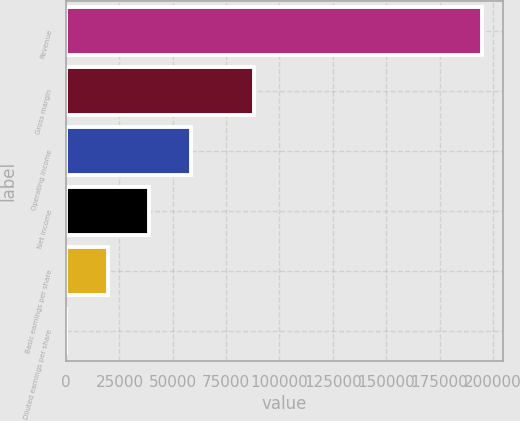Convert chart. <chart><loc_0><loc_0><loc_500><loc_500><bar_chart><fcel>Revenue<fcel>Gross margin<fcel>Operating income<fcel>Net income<fcel>Basic earnings per share<fcel>Diluted earnings per share<nl><fcel>195037<fcel>88116<fcel>58511.2<fcel>39007.5<fcel>19503.8<fcel>0.1<nl></chart> 